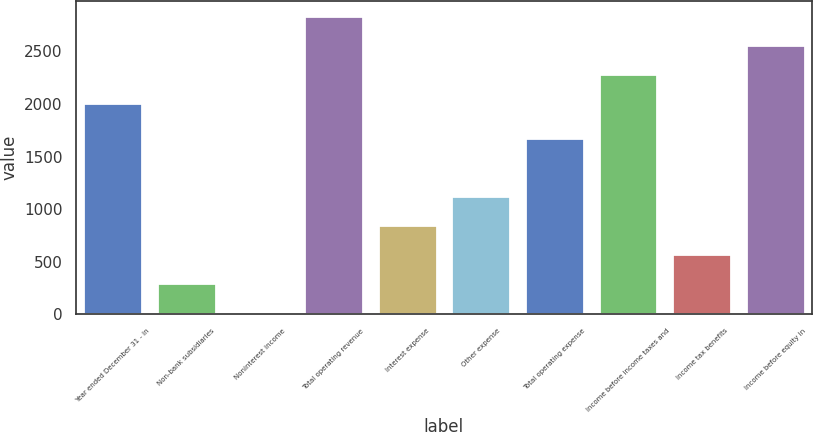<chart> <loc_0><loc_0><loc_500><loc_500><bar_chart><fcel>Year ended December 31 - in<fcel>Non-bank subsidiaries<fcel>Noninterest income<fcel>Total operating revenue<fcel>Interest expense<fcel>Other expense<fcel>Total operating expense<fcel>Income before income taxes and<fcel>Income tax benefits<fcel>Income before equity in<nl><fcel>2012<fcel>297.1<fcel>22<fcel>2837.3<fcel>847.3<fcel>1122.4<fcel>1672.6<fcel>2287.1<fcel>572.2<fcel>2562.2<nl></chart> 